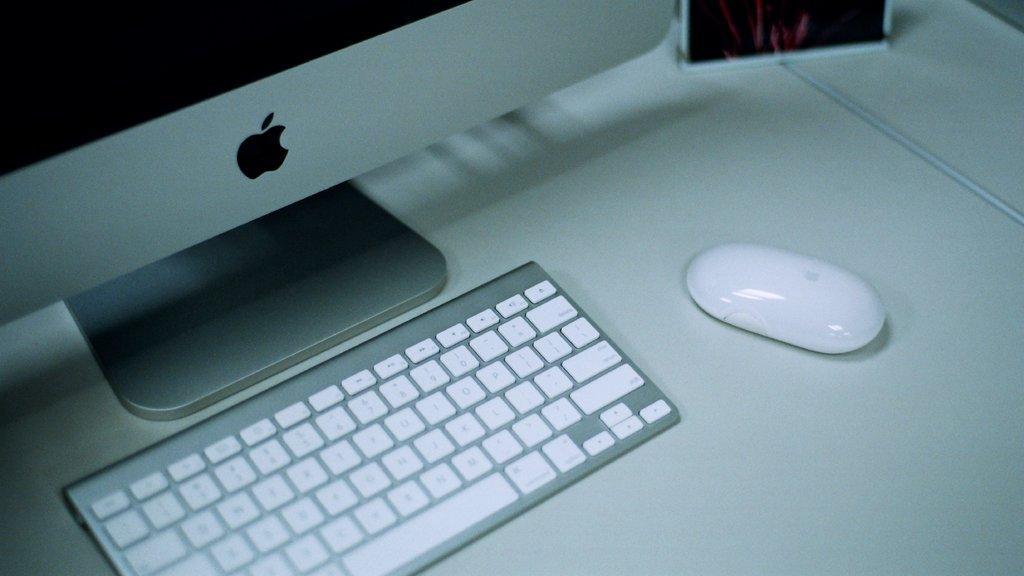Could you give a brief overview of what you see in this image? In this image we can see a monitor ,keyboard and mouse placed on a table. 